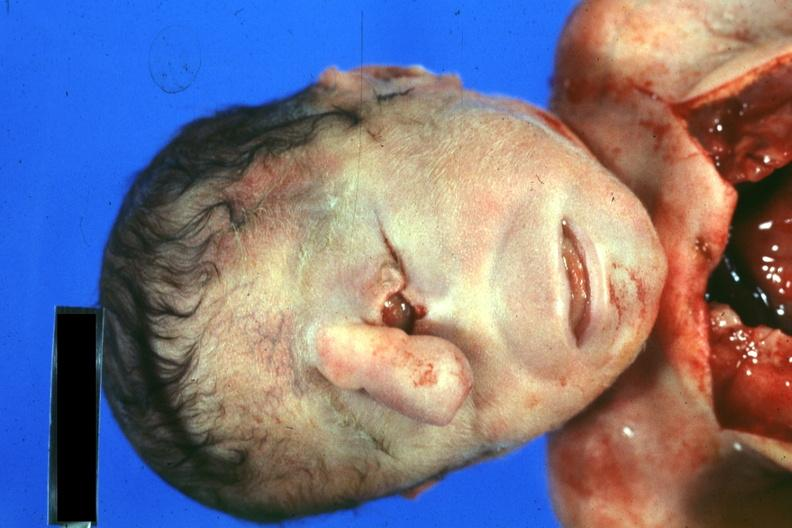s cyclops present?
Answer the question using a single word or phrase. Yes 